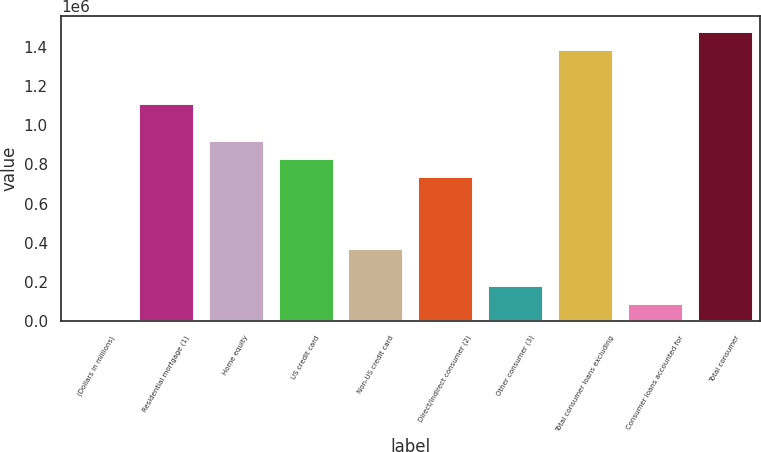Convert chart to OTSL. <chart><loc_0><loc_0><loc_500><loc_500><bar_chart><fcel>(Dollars in millions)<fcel>Residential mortgage (1)<fcel>Home equity<fcel>US credit card<fcel>Non-US credit card<fcel>Direct/Indirect consumer (2)<fcel>Other consumer (3)<fcel>Total consumer loans excluding<fcel>Consumer loans accounted for<fcel>Total consumer<nl><fcel>2011<fcel>1.11104e+06<fcel>926200<fcel>833781<fcel>371687<fcel>741362<fcel>186849<fcel>1.38829e+06<fcel>94429.9<fcel>1.48071e+06<nl></chart> 